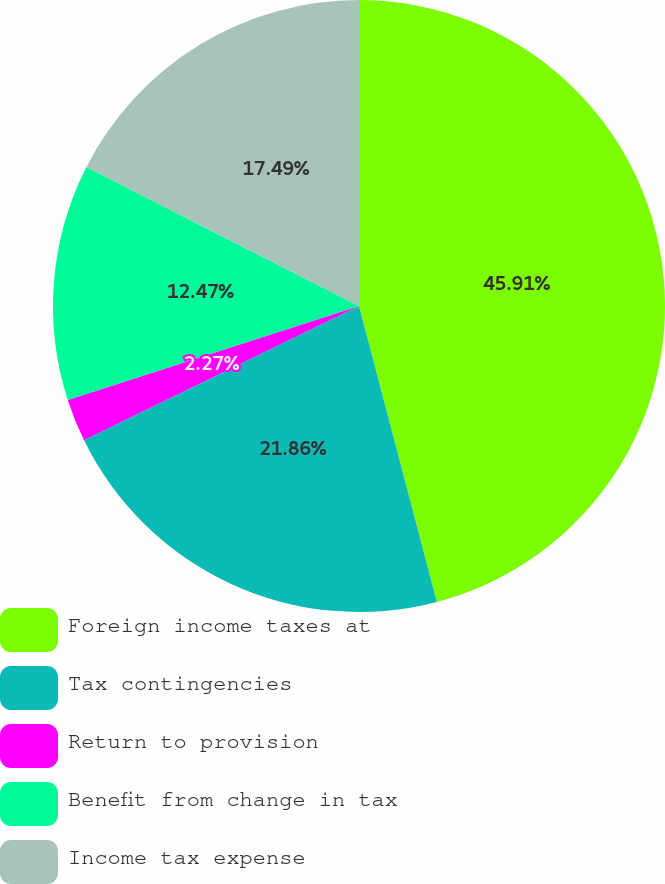<chart> <loc_0><loc_0><loc_500><loc_500><pie_chart><fcel>Foreign income taxes at<fcel>Tax contingencies<fcel>Return to provision<fcel>Benefit from change in tax<fcel>Income tax expense<nl><fcel>45.9%<fcel>21.86%<fcel>2.27%<fcel>12.47%<fcel>17.49%<nl></chart> 